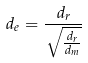<formula> <loc_0><loc_0><loc_500><loc_500>d _ { e } = \frac { d _ { r } } { \sqrt { \frac { d _ { r } } { d _ { m } } } }</formula> 